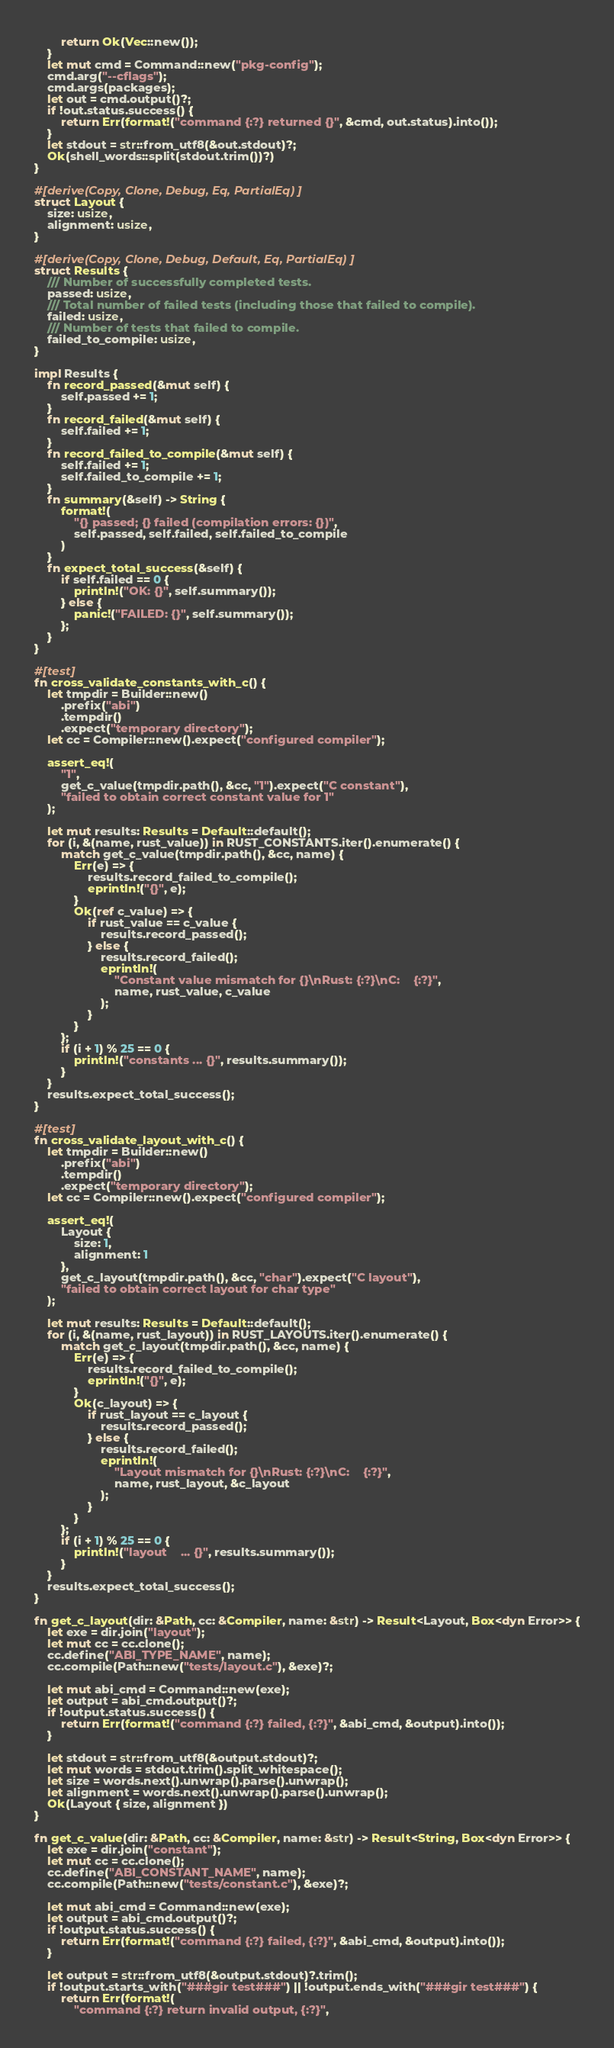<code> <loc_0><loc_0><loc_500><loc_500><_Rust_>        return Ok(Vec::new());
    }
    let mut cmd = Command::new("pkg-config");
    cmd.arg("--cflags");
    cmd.args(packages);
    let out = cmd.output()?;
    if !out.status.success() {
        return Err(format!("command {:?} returned {}", &cmd, out.status).into());
    }
    let stdout = str::from_utf8(&out.stdout)?;
    Ok(shell_words::split(stdout.trim())?)
}

#[derive(Copy, Clone, Debug, Eq, PartialEq)]
struct Layout {
    size: usize,
    alignment: usize,
}

#[derive(Copy, Clone, Debug, Default, Eq, PartialEq)]
struct Results {
    /// Number of successfully completed tests.
    passed: usize,
    /// Total number of failed tests (including those that failed to compile).
    failed: usize,
    /// Number of tests that failed to compile.
    failed_to_compile: usize,
}

impl Results {
    fn record_passed(&mut self) {
        self.passed += 1;
    }
    fn record_failed(&mut self) {
        self.failed += 1;
    }
    fn record_failed_to_compile(&mut self) {
        self.failed += 1;
        self.failed_to_compile += 1;
    }
    fn summary(&self) -> String {
        format!(
            "{} passed; {} failed (compilation errors: {})",
            self.passed, self.failed, self.failed_to_compile
        )
    }
    fn expect_total_success(&self) {
        if self.failed == 0 {
            println!("OK: {}", self.summary());
        } else {
            panic!("FAILED: {}", self.summary());
        };
    }
}

#[test]
fn cross_validate_constants_with_c() {
    let tmpdir = Builder::new()
        .prefix("abi")
        .tempdir()
        .expect("temporary directory");
    let cc = Compiler::new().expect("configured compiler");

    assert_eq!(
        "1",
        get_c_value(tmpdir.path(), &cc, "1").expect("C constant"),
        "failed to obtain correct constant value for 1"
    );

    let mut results: Results = Default::default();
    for (i, &(name, rust_value)) in RUST_CONSTANTS.iter().enumerate() {
        match get_c_value(tmpdir.path(), &cc, name) {
            Err(e) => {
                results.record_failed_to_compile();
                eprintln!("{}", e);
            }
            Ok(ref c_value) => {
                if rust_value == c_value {
                    results.record_passed();
                } else {
                    results.record_failed();
                    eprintln!(
                        "Constant value mismatch for {}\nRust: {:?}\nC:    {:?}",
                        name, rust_value, c_value
                    );
                }
            }
        };
        if (i + 1) % 25 == 0 {
            println!("constants ... {}", results.summary());
        }
    }
    results.expect_total_success();
}

#[test]
fn cross_validate_layout_with_c() {
    let tmpdir = Builder::new()
        .prefix("abi")
        .tempdir()
        .expect("temporary directory");
    let cc = Compiler::new().expect("configured compiler");

    assert_eq!(
        Layout {
            size: 1,
            alignment: 1
        },
        get_c_layout(tmpdir.path(), &cc, "char").expect("C layout"),
        "failed to obtain correct layout for char type"
    );

    let mut results: Results = Default::default();
    for (i, &(name, rust_layout)) in RUST_LAYOUTS.iter().enumerate() {
        match get_c_layout(tmpdir.path(), &cc, name) {
            Err(e) => {
                results.record_failed_to_compile();
                eprintln!("{}", e);
            }
            Ok(c_layout) => {
                if rust_layout == c_layout {
                    results.record_passed();
                } else {
                    results.record_failed();
                    eprintln!(
                        "Layout mismatch for {}\nRust: {:?}\nC:    {:?}",
                        name, rust_layout, &c_layout
                    );
                }
            }
        };
        if (i + 1) % 25 == 0 {
            println!("layout    ... {}", results.summary());
        }
    }
    results.expect_total_success();
}

fn get_c_layout(dir: &Path, cc: &Compiler, name: &str) -> Result<Layout, Box<dyn Error>> {
    let exe = dir.join("layout");
    let mut cc = cc.clone();
    cc.define("ABI_TYPE_NAME", name);
    cc.compile(Path::new("tests/layout.c"), &exe)?;

    let mut abi_cmd = Command::new(exe);
    let output = abi_cmd.output()?;
    if !output.status.success() {
        return Err(format!("command {:?} failed, {:?}", &abi_cmd, &output).into());
    }

    let stdout = str::from_utf8(&output.stdout)?;
    let mut words = stdout.trim().split_whitespace();
    let size = words.next().unwrap().parse().unwrap();
    let alignment = words.next().unwrap().parse().unwrap();
    Ok(Layout { size, alignment })
}

fn get_c_value(dir: &Path, cc: &Compiler, name: &str) -> Result<String, Box<dyn Error>> {
    let exe = dir.join("constant");
    let mut cc = cc.clone();
    cc.define("ABI_CONSTANT_NAME", name);
    cc.compile(Path::new("tests/constant.c"), &exe)?;

    let mut abi_cmd = Command::new(exe);
    let output = abi_cmd.output()?;
    if !output.status.success() {
        return Err(format!("command {:?} failed, {:?}", &abi_cmd, &output).into());
    }

    let output = str::from_utf8(&output.stdout)?.trim();
    if !output.starts_with("###gir test###") || !output.ends_with("###gir test###") {
        return Err(format!(
            "command {:?} return invalid output, {:?}",</code> 